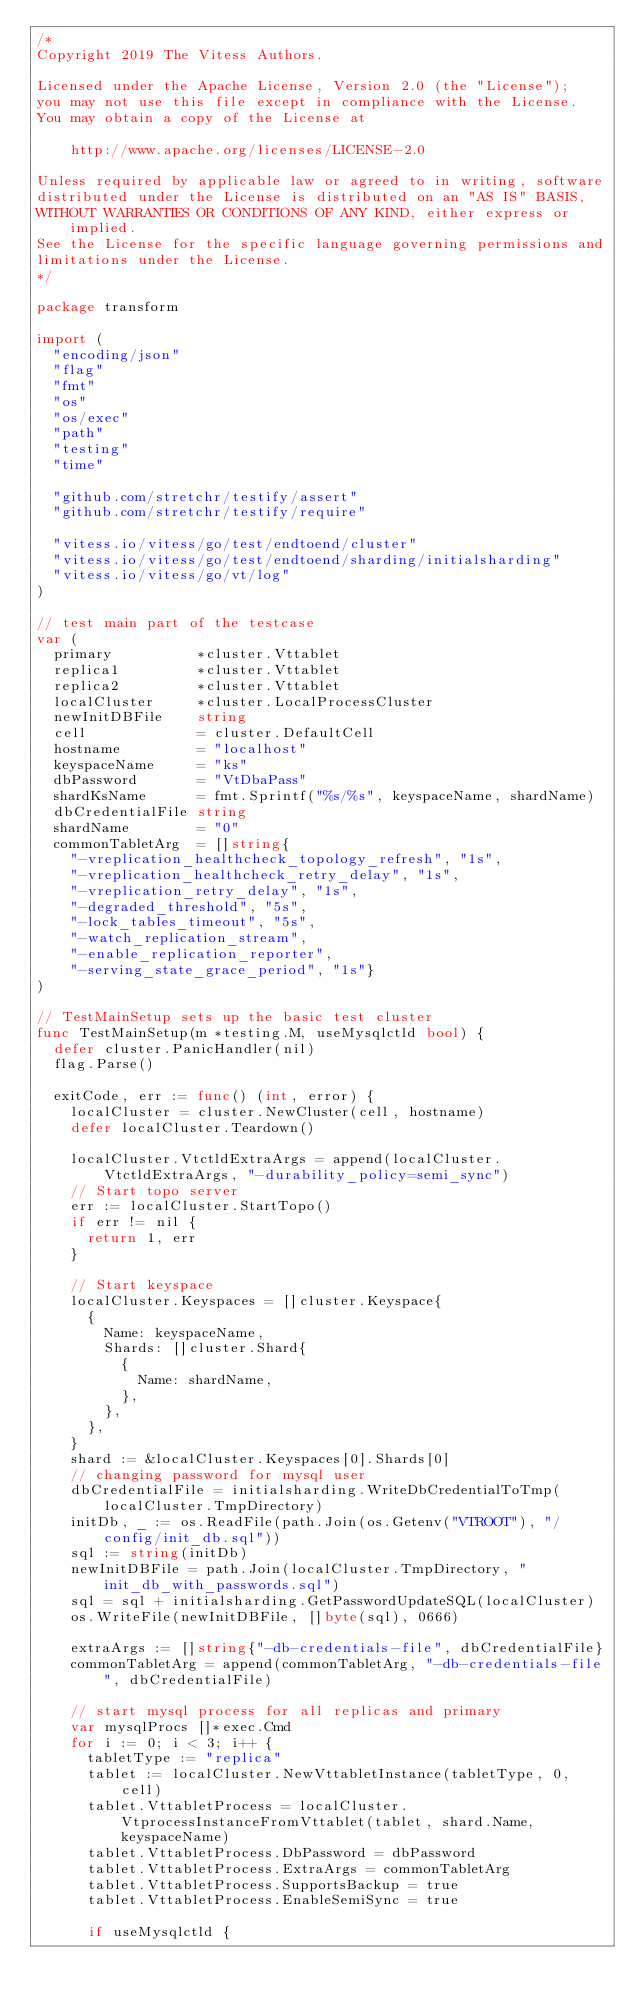Convert code to text. <code><loc_0><loc_0><loc_500><loc_500><_Go_>/*
Copyright 2019 The Vitess Authors.

Licensed under the Apache License, Version 2.0 (the "License");
you may not use this file except in compliance with the License.
You may obtain a copy of the License at

    http://www.apache.org/licenses/LICENSE-2.0

Unless required by applicable law or agreed to in writing, software
distributed under the License is distributed on an "AS IS" BASIS,
WITHOUT WARRANTIES OR CONDITIONS OF ANY KIND, either express or implied.
See the License for the specific language governing permissions and
limitations under the License.
*/

package transform

import (
	"encoding/json"
	"flag"
	"fmt"
	"os"
	"os/exec"
	"path"
	"testing"
	"time"

	"github.com/stretchr/testify/assert"
	"github.com/stretchr/testify/require"

	"vitess.io/vitess/go/test/endtoend/cluster"
	"vitess.io/vitess/go/test/endtoend/sharding/initialsharding"
	"vitess.io/vitess/go/vt/log"
)

// test main part of the testcase
var (
	primary          *cluster.Vttablet
	replica1         *cluster.Vttablet
	replica2         *cluster.Vttablet
	localCluster     *cluster.LocalProcessCluster
	newInitDBFile    string
	cell             = cluster.DefaultCell
	hostname         = "localhost"
	keyspaceName     = "ks"
	dbPassword       = "VtDbaPass"
	shardKsName      = fmt.Sprintf("%s/%s", keyspaceName, shardName)
	dbCredentialFile string
	shardName        = "0"
	commonTabletArg  = []string{
		"-vreplication_healthcheck_topology_refresh", "1s",
		"-vreplication_healthcheck_retry_delay", "1s",
		"-vreplication_retry_delay", "1s",
		"-degraded_threshold", "5s",
		"-lock_tables_timeout", "5s",
		"-watch_replication_stream",
		"-enable_replication_reporter",
		"-serving_state_grace_period", "1s"}
)

// TestMainSetup sets up the basic test cluster
func TestMainSetup(m *testing.M, useMysqlctld bool) {
	defer cluster.PanicHandler(nil)
	flag.Parse()

	exitCode, err := func() (int, error) {
		localCluster = cluster.NewCluster(cell, hostname)
		defer localCluster.Teardown()

		localCluster.VtctldExtraArgs = append(localCluster.VtctldExtraArgs, "-durability_policy=semi_sync")
		// Start topo server
		err := localCluster.StartTopo()
		if err != nil {
			return 1, err
		}

		// Start keyspace
		localCluster.Keyspaces = []cluster.Keyspace{
			{
				Name: keyspaceName,
				Shards: []cluster.Shard{
					{
						Name: shardName,
					},
				},
			},
		}
		shard := &localCluster.Keyspaces[0].Shards[0]
		// changing password for mysql user
		dbCredentialFile = initialsharding.WriteDbCredentialToTmp(localCluster.TmpDirectory)
		initDb, _ := os.ReadFile(path.Join(os.Getenv("VTROOT"), "/config/init_db.sql"))
		sql := string(initDb)
		newInitDBFile = path.Join(localCluster.TmpDirectory, "init_db_with_passwords.sql")
		sql = sql + initialsharding.GetPasswordUpdateSQL(localCluster)
		os.WriteFile(newInitDBFile, []byte(sql), 0666)

		extraArgs := []string{"-db-credentials-file", dbCredentialFile}
		commonTabletArg = append(commonTabletArg, "-db-credentials-file", dbCredentialFile)

		// start mysql process for all replicas and primary
		var mysqlProcs []*exec.Cmd
		for i := 0; i < 3; i++ {
			tabletType := "replica"
			tablet := localCluster.NewVttabletInstance(tabletType, 0, cell)
			tablet.VttabletProcess = localCluster.VtprocessInstanceFromVttablet(tablet, shard.Name, keyspaceName)
			tablet.VttabletProcess.DbPassword = dbPassword
			tablet.VttabletProcess.ExtraArgs = commonTabletArg
			tablet.VttabletProcess.SupportsBackup = true
			tablet.VttabletProcess.EnableSemiSync = true

			if useMysqlctld {</code> 